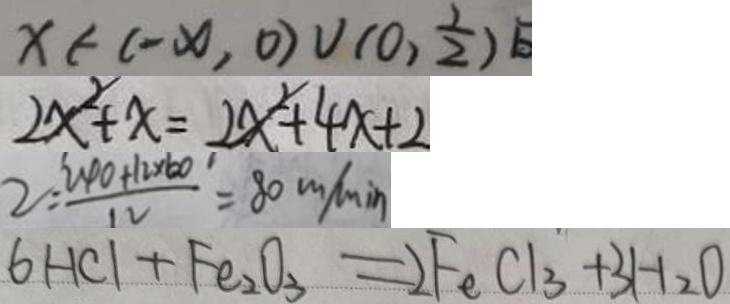<formula> <loc_0><loc_0><loc_500><loc_500>x \in ( - x , 0 ) \cup ( 0 , \frac { 1 } { 2 } ) 
 2 x ^ { 2 } + x = 2 x ^ { 2 } + 4 x + 2 
 2 = \frac { 2 4 0 + 1 2 \times 6 0 } { 1 2 } = 8 0 m / \min 
 6 H C l + F e _ { 2 } O _ { 3 } = 2 F e C l _ { 3 } + 3 H _ { 2 } O</formula> 